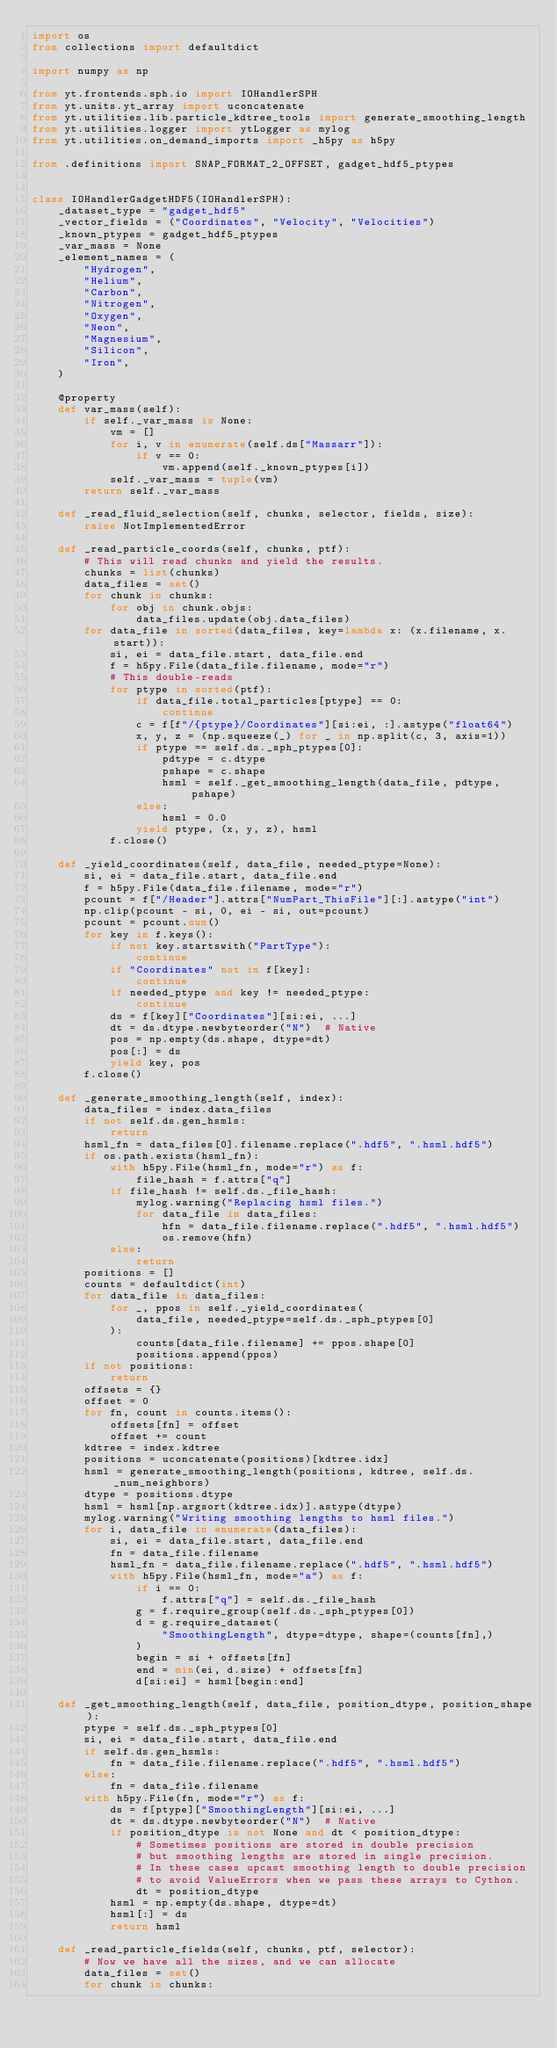<code> <loc_0><loc_0><loc_500><loc_500><_Python_>import os
from collections import defaultdict

import numpy as np

from yt.frontends.sph.io import IOHandlerSPH
from yt.units.yt_array import uconcatenate
from yt.utilities.lib.particle_kdtree_tools import generate_smoothing_length
from yt.utilities.logger import ytLogger as mylog
from yt.utilities.on_demand_imports import _h5py as h5py

from .definitions import SNAP_FORMAT_2_OFFSET, gadget_hdf5_ptypes


class IOHandlerGadgetHDF5(IOHandlerSPH):
    _dataset_type = "gadget_hdf5"
    _vector_fields = ("Coordinates", "Velocity", "Velocities")
    _known_ptypes = gadget_hdf5_ptypes
    _var_mass = None
    _element_names = (
        "Hydrogen",
        "Helium",
        "Carbon",
        "Nitrogen",
        "Oxygen",
        "Neon",
        "Magnesium",
        "Silicon",
        "Iron",
    )

    @property
    def var_mass(self):
        if self._var_mass is None:
            vm = []
            for i, v in enumerate(self.ds["Massarr"]):
                if v == 0:
                    vm.append(self._known_ptypes[i])
            self._var_mass = tuple(vm)
        return self._var_mass

    def _read_fluid_selection(self, chunks, selector, fields, size):
        raise NotImplementedError

    def _read_particle_coords(self, chunks, ptf):
        # This will read chunks and yield the results.
        chunks = list(chunks)
        data_files = set()
        for chunk in chunks:
            for obj in chunk.objs:
                data_files.update(obj.data_files)
        for data_file in sorted(data_files, key=lambda x: (x.filename, x.start)):
            si, ei = data_file.start, data_file.end
            f = h5py.File(data_file.filename, mode="r")
            # This double-reads
            for ptype in sorted(ptf):
                if data_file.total_particles[ptype] == 0:
                    continue
                c = f[f"/{ptype}/Coordinates"][si:ei, :].astype("float64")
                x, y, z = (np.squeeze(_) for _ in np.split(c, 3, axis=1))
                if ptype == self.ds._sph_ptypes[0]:
                    pdtype = c.dtype
                    pshape = c.shape
                    hsml = self._get_smoothing_length(data_file, pdtype, pshape)
                else:
                    hsml = 0.0
                yield ptype, (x, y, z), hsml
            f.close()

    def _yield_coordinates(self, data_file, needed_ptype=None):
        si, ei = data_file.start, data_file.end
        f = h5py.File(data_file.filename, mode="r")
        pcount = f["/Header"].attrs["NumPart_ThisFile"][:].astype("int")
        np.clip(pcount - si, 0, ei - si, out=pcount)
        pcount = pcount.sum()
        for key in f.keys():
            if not key.startswith("PartType"):
                continue
            if "Coordinates" not in f[key]:
                continue
            if needed_ptype and key != needed_ptype:
                continue
            ds = f[key]["Coordinates"][si:ei, ...]
            dt = ds.dtype.newbyteorder("N")  # Native
            pos = np.empty(ds.shape, dtype=dt)
            pos[:] = ds
            yield key, pos
        f.close()

    def _generate_smoothing_length(self, index):
        data_files = index.data_files
        if not self.ds.gen_hsmls:
            return
        hsml_fn = data_files[0].filename.replace(".hdf5", ".hsml.hdf5")
        if os.path.exists(hsml_fn):
            with h5py.File(hsml_fn, mode="r") as f:
                file_hash = f.attrs["q"]
            if file_hash != self.ds._file_hash:
                mylog.warning("Replacing hsml files.")
                for data_file in data_files:
                    hfn = data_file.filename.replace(".hdf5", ".hsml.hdf5")
                    os.remove(hfn)
            else:
                return
        positions = []
        counts = defaultdict(int)
        for data_file in data_files:
            for _, ppos in self._yield_coordinates(
                data_file, needed_ptype=self.ds._sph_ptypes[0]
            ):
                counts[data_file.filename] += ppos.shape[0]
                positions.append(ppos)
        if not positions:
            return
        offsets = {}
        offset = 0
        for fn, count in counts.items():
            offsets[fn] = offset
            offset += count
        kdtree = index.kdtree
        positions = uconcatenate(positions)[kdtree.idx]
        hsml = generate_smoothing_length(positions, kdtree, self.ds._num_neighbors)
        dtype = positions.dtype
        hsml = hsml[np.argsort(kdtree.idx)].astype(dtype)
        mylog.warning("Writing smoothing lengths to hsml files.")
        for i, data_file in enumerate(data_files):
            si, ei = data_file.start, data_file.end
            fn = data_file.filename
            hsml_fn = data_file.filename.replace(".hdf5", ".hsml.hdf5")
            with h5py.File(hsml_fn, mode="a") as f:
                if i == 0:
                    f.attrs["q"] = self.ds._file_hash
                g = f.require_group(self.ds._sph_ptypes[0])
                d = g.require_dataset(
                    "SmoothingLength", dtype=dtype, shape=(counts[fn],)
                )
                begin = si + offsets[fn]
                end = min(ei, d.size) + offsets[fn]
                d[si:ei] = hsml[begin:end]

    def _get_smoothing_length(self, data_file, position_dtype, position_shape):
        ptype = self.ds._sph_ptypes[0]
        si, ei = data_file.start, data_file.end
        if self.ds.gen_hsmls:
            fn = data_file.filename.replace(".hdf5", ".hsml.hdf5")
        else:
            fn = data_file.filename
        with h5py.File(fn, mode="r") as f:
            ds = f[ptype]["SmoothingLength"][si:ei, ...]
            dt = ds.dtype.newbyteorder("N")  # Native
            if position_dtype is not None and dt < position_dtype:
                # Sometimes positions are stored in double precision
                # but smoothing lengths are stored in single precision.
                # In these cases upcast smoothing length to double precision
                # to avoid ValueErrors when we pass these arrays to Cython.
                dt = position_dtype
            hsml = np.empty(ds.shape, dtype=dt)
            hsml[:] = ds
            return hsml

    def _read_particle_fields(self, chunks, ptf, selector):
        # Now we have all the sizes, and we can allocate
        data_files = set()
        for chunk in chunks:</code> 